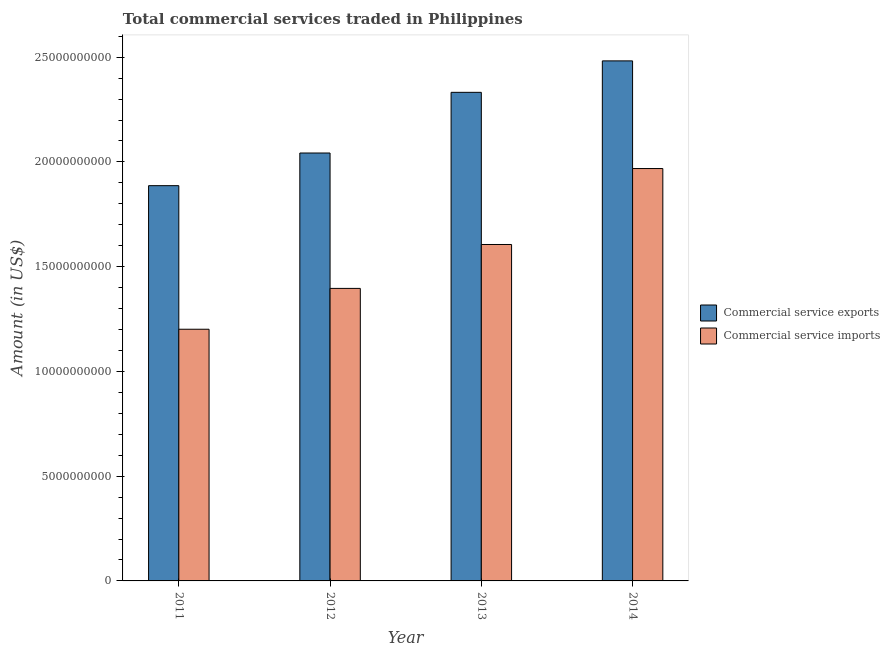Are the number of bars per tick equal to the number of legend labels?
Give a very brief answer. Yes. How many bars are there on the 1st tick from the left?
Your response must be concise. 2. What is the label of the 4th group of bars from the left?
Ensure brevity in your answer.  2014. What is the amount of commercial service imports in 2013?
Keep it short and to the point. 1.61e+1. Across all years, what is the maximum amount of commercial service imports?
Provide a short and direct response. 1.97e+1. Across all years, what is the minimum amount of commercial service imports?
Offer a very short reply. 1.20e+1. In which year was the amount of commercial service exports maximum?
Your answer should be compact. 2014. What is the total amount of commercial service exports in the graph?
Provide a succinct answer. 8.74e+1. What is the difference between the amount of commercial service exports in 2011 and that in 2014?
Make the answer very short. -5.96e+09. What is the difference between the amount of commercial service exports in 2012 and the amount of commercial service imports in 2014?
Give a very brief answer. -4.40e+09. What is the average amount of commercial service exports per year?
Provide a succinct answer. 2.19e+1. In the year 2014, what is the difference between the amount of commercial service exports and amount of commercial service imports?
Your response must be concise. 0. What is the ratio of the amount of commercial service exports in 2012 to that in 2014?
Provide a short and direct response. 0.82. Is the amount of commercial service exports in 2012 less than that in 2014?
Your answer should be compact. Yes. What is the difference between the highest and the second highest amount of commercial service imports?
Your response must be concise. 3.63e+09. What is the difference between the highest and the lowest amount of commercial service imports?
Keep it short and to the point. 7.67e+09. In how many years, is the amount of commercial service imports greater than the average amount of commercial service imports taken over all years?
Provide a succinct answer. 2. Is the sum of the amount of commercial service exports in 2011 and 2013 greater than the maximum amount of commercial service imports across all years?
Provide a succinct answer. Yes. What does the 1st bar from the left in 2014 represents?
Give a very brief answer. Commercial service exports. What does the 2nd bar from the right in 2012 represents?
Give a very brief answer. Commercial service exports. How many years are there in the graph?
Your response must be concise. 4. Are the values on the major ticks of Y-axis written in scientific E-notation?
Your response must be concise. No. Does the graph contain grids?
Ensure brevity in your answer.  No. Where does the legend appear in the graph?
Your answer should be very brief. Center right. How many legend labels are there?
Offer a very short reply. 2. What is the title of the graph?
Offer a very short reply. Total commercial services traded in Philippines. Does "Time to import" appear as one of the legend labels in the graph?
Offer a very short reply. No. What is the label or title of the Y-axis?
Keep it short and to the point. Amount (in US$). What is the Amount (in US$) in Commercial service exports in 2011?
Your response must be concise. 1.89e+1. What is the Amount (in US$) of Commercial service imports in 2011?
Provide a succinct answer. 1.20e+1. What is the Amount (in US$) in Commercial service exports in 2012?
Provide a short and direct response. 2.04e+1. What is the Amount (in US$) of Commercial service imports in 2012?
Your answer should be compact. 1.40e+1. What is the Amount (in US$) of Commercial service exports in 2013?
Provide a succinct answer. 2.33e+1. What is the Amount (in US$) in Commercial service imports in 2013?
Give a very brief answer. 1.61e+1. What is the Amount (in US$) of Commercial service exports in 2014?
Your answer should be very brief. 2.48e+1. What is the Amount (in US$) of Commercial service imports in 2014?
Give a very brief answer. 1.97e+1. Across all years, what is the maximum Amount (in US$) of Commercial service exports?
Provide a short and direct response. 2.48e+1. Across all years, what is the maximum Amount (in US$) in Commercial service imports?
Give a very brief answer. 1.97e+1. Across all years, what is the minimum Amount (in US$) of Commercial service exports?
Ensure brevity in your answer.  1.89e+1. Across all years, what is the minimum Amount (in US$) in Commercial service imports?
Your answer should be compact. 1.20e+1. What is the total Amount (in US$) of Commercial service exports in the graph?
Your answer should be compact. 8.74e+1. What is the total Amount (in US$) of Commercial service imports in the graph?
Ensure brevity in your answer.  6.17e+1. What is the difference between the Amount (in US$) in Commercial service exports in 2011 and that in 2012?
Provide a succinct answer. -1.56e+09. What is the difference between the Amount (in US$) of Commercial service imports in 2011 and that in 2012?
Keep it short and to the point. -1.95e+09. What is the difference between the Amount (in US$) in Commercial service exports in 2011 and that in 2013?
Make the answer very short. -4.46e+09. What is the difference between the Amount (in US$) of Commercial service imports in 2011 and that in 2013?
Offer a terse response. -4.04e+09. What is the difference between the Amount (in US$) in Commercial service exports in 2011 and that in 2014?
Provide a succinct answer. -5.96e+09. What is the difference between the Amount (in US$) of Commercial service imports in 2011 and that in 2014?
Offer a very short reply. -7.67e+09. What is the difference between the Amount (in US$) in Commercial service exports in 2012 and that in 2013?
Your answer should be very brief. -2.90e+09. What is the difference between the Amount (in US$) in Commercial service imports in 2012 and that in 2013?
Your response must be concise. -2.10e+09. What is the difference between the Amount (in US$) of Commercial service exports in 2012 and that in 2014?
Your response must be concise. -4.40e+09. What is the difference between the Amount (in US$) of Commercial service imports in 2012 and that in 2014?
Your answer should be very brief. -5.72e+09. What is the difference between the Amount (in US$) in Commercial service exports in 2013 and that in 2014?
Give a very brief answer. -1.50e+09. What is the difference between the Amount (in US$) in Commercial service imports in 2013 and that in 2014?
Your answer should be very brief. -3.63e+09. What is the difference between the Amount (in US$) of Commercial service exports in 2011 and the Amount (in US$) of Commercial service imports in 2012?
Offer a terse response. 4.90e+09. What is the difference between the Amount (in US$) in Commercial service exports in 2011 and the Amount (in US$) in Commercial service imports in 2013?
Keep it short and to the point. 2.81e+09. What is the difference between the Amount (in US$) in Commercial service exports in 2011 and the Amount (in US$) in Commercial service imports in 2014?
Provide a short and direct response. -8.18e+08. What is the difference between the Amount (in US$) in Commercial service exports in 2012 and the Amount (in US$) in Commercial service imports in 2013?
Provide a succinct answer. 4.37e+09. What is the difference between the Amount (in US$) in Commercial service exports in 2012 and the Amount (in US$) in Commercial service imports in 2014?
Make the answer very short. 7.41e+08. What is the difference between the Amount (in US$) in Commercial service exports in 2013 and the Amount (in US$) in Commercial service imports in 2014?
Keep it short and to the point. 3.64e+09. What is the average Amount (in US$) of Commercial service exports per year?
Your answer should be compact. 2.19e+1. What is the average Amount (in US$) of Commercial service imports per year?
Offer a terse response. 1.54e+1. In the year 2011, what is the difference between the Amount (in US$) in Commercial service exports and Amount (in US$) in Commercial service imports?
Provide a short and direct response. 6.85e+09. In the year 2012, what is the difference between the Amount (in US$) in Commercial service exports and Amount (in US$) in Commercial service imports?
Provide a short and direct response. 6.46e+09. In the year 2013, what is the difference between the Amount (in US$) of Commercial service exports and Amount (in US$) of Commercial service imports?
Your answer should be very brief. 7.26e+09. In the year 2014, what is the difference between the Amount (in US$) in Commercial service exports and Amount (in US$) in Commercial service imports?
Provide a short and direct response. 5.14e+09. What is the ratio of the Amount (in US$) in Commercial service exports in 2011 to that in 2012?
Your answer should be very brief. 0.92. What is the ratio of the Amount (in US$) of Commercial service imports in 2011 to that in 2012?
Give a very brief answer. 0.86. What is the ratio of the Amount (in US$) in Commercial service exports in 2011 to that in 2013?
Make the answer very short. 0.81. What is the ratio of the Amount (in US$) of Commercial service imports in 2011 to that in 2013?
Give a very brief answer. 0.75. What is the ratio of the Amount (in US$) of Commercial service exports in 2011 to that in 2014?
Ensure brevity in your answer.  0.76. What is the ratio of the Amount (in US$) of Commercial service imports in 2011 to that in 2014?
Make the answer very short. 0.61. What is the ratio of the Amount (in US$) in Commercial service exports in 2012 to that in 2013?
Make the answer very short. 0.88. What is the ratio of the Amount (in US$) of Commercial service imports in 2012 to that in 2013?
Ensure brevity in your answer.  0.87. What is the ratio of the Amount (in US$) of Commercial service exports in 2012 to that in 2014?
Make the answer very short. 0.82. What is the ratio of the Amount (in US$) in Commercial service imports in 2012 to that in 2014?
Ensure brevity in your answer.  0.71. What is the ratio of the Amount (in US$) of Commercial service exports in 2013 to that in 2014?
Give a very brief answer. 0.94. What is the ratio of the Amount (in US$) in Commercial service imports in 2013 to that in 2014?
Your answer should be very brief. 0.82. What is the difference between the highest and the second highest Amount (in US$) of Commercial service exports?
Provide a short and direct response. 1.50e+09. What is the difference between the highest and the second highest Amount (in US$) of Commercial service imports?
Ensure brevity in your answer.  3.63e+09. What is the difference between the highest and the lowest Amount (in US$) in Commercial service exports?
Keep it short and to the point. 5.96e+09. What is the difference between the highest and the lowest Amount (in US$) in Commercial service imports?
Your answer should be very brief. 7.67e+09. 